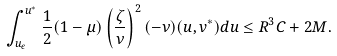<formula> <loc_0><loc_0><loc_500><loc_500>\int _ { u _ { \epsilon } } ^ { u ^ { * } } { \frac { 1 } { 2 } ( 1 - \mu ) \left ( \frac { \zeta } { \nu } \right ) ^ { 2 } ( - \nu ) ( u , v ^ { * } ) d u } \leq R ^ { 3 } C + 2 M .</formula> 